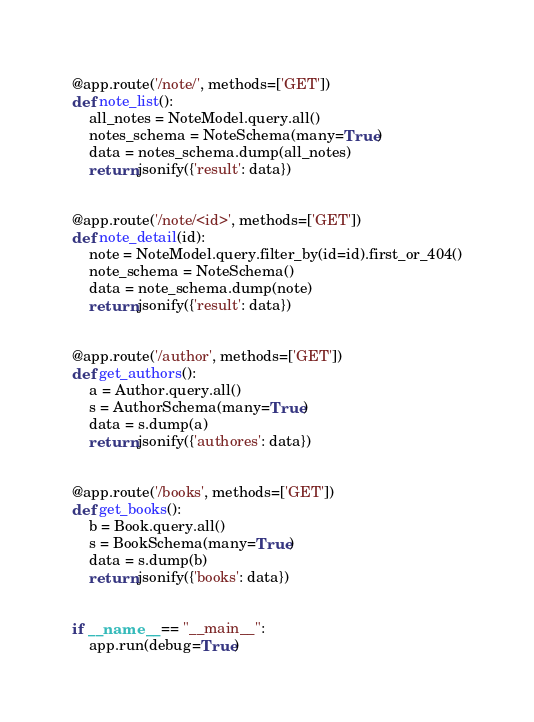<code> <loc_0><loc_0><loc_500><loc_500><_Python_>
@app.route('/note/', methods=['GET'])
def note_list():
    all_notes = NoteModel.query.all()
    notes_schema = NoteSchema(many=True)
    data = notes_schema.dump(all_notes)
    return jsonify({'result': data})


@app.route('/note/<id>', methods=['GET'])
def note_detail(id):
    note = NoteModel.query.filter_by(id=id).first_or_404()
    note_schema = NoteSchema()
    data = note_schema.dump(note)
    return jsonify({'result': data})


@app.route('/author', methods=['GET'])
def get_authors():
    a = Author.query.all()
    s = AuthorSchema(many=True)
    data = s.dump(a)
    return jsonify({'authores': data})


@app.route('/books', methods=['GET'])
def get_books():
    b = Book.query.all()
    s = BookSchema(many=True)
    data = s.dump(b)
    return jsonify({'books': data})


if __name__ == "__main__":
    app.run(debug=True)
</code> 